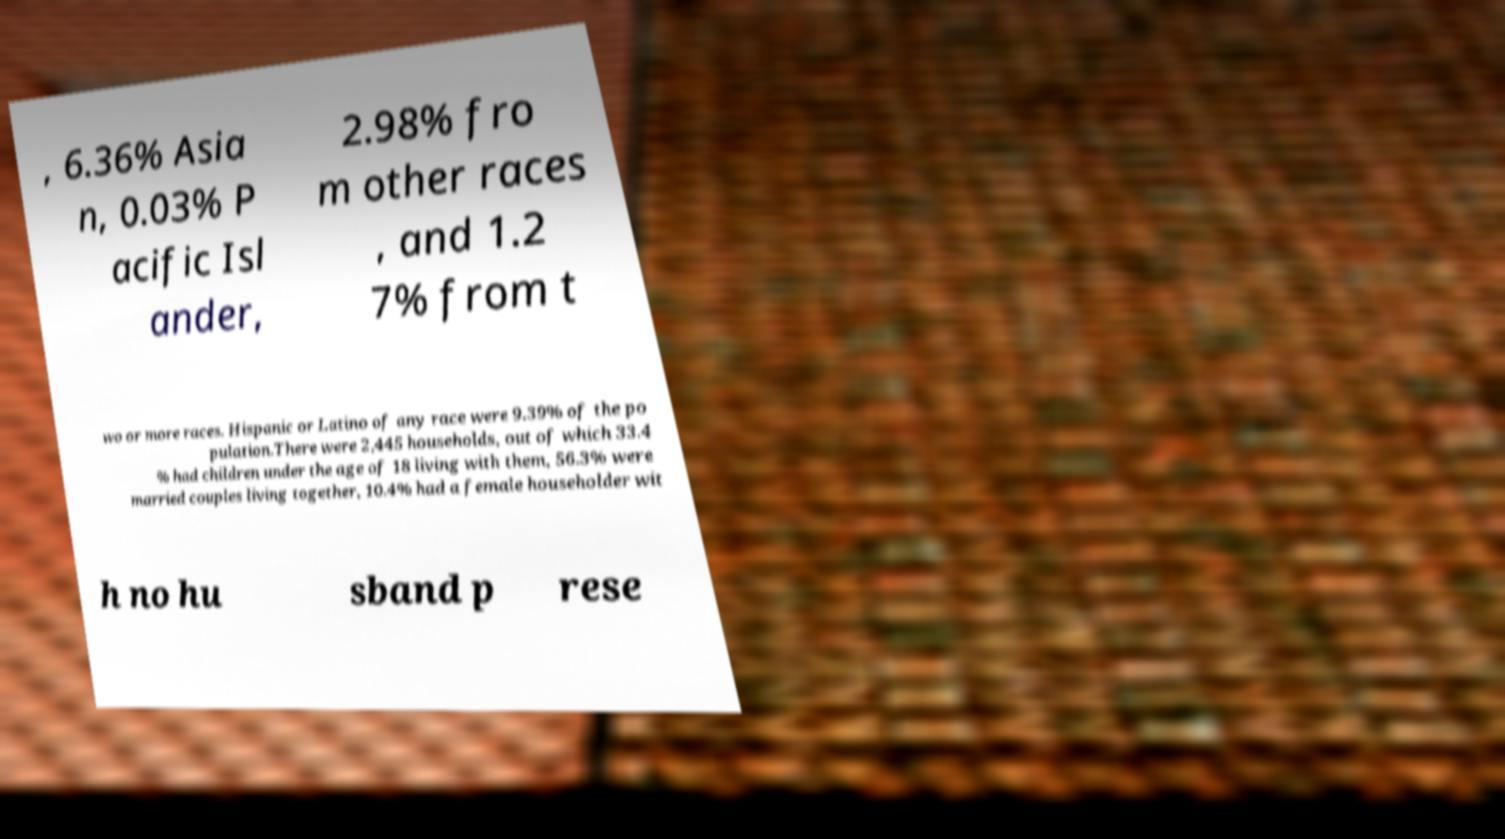Can you read and provide the text displayed in the image?This photo seems to have some interesting text. Can you extract and type it out for me? , 6.36% Asia n, 0.03% P acific Isl ander, 2.98% fro m other races , and 1.2 7% from t wo or more races. Hispanic or Latino of any race were 9.39% of the po pulation.There were 2,445 households, out of which 33.4 % had children under the age of 18 living with them, 56.3% were married couples living together, 10.4% had a female householder wit h no hu sband p rese 